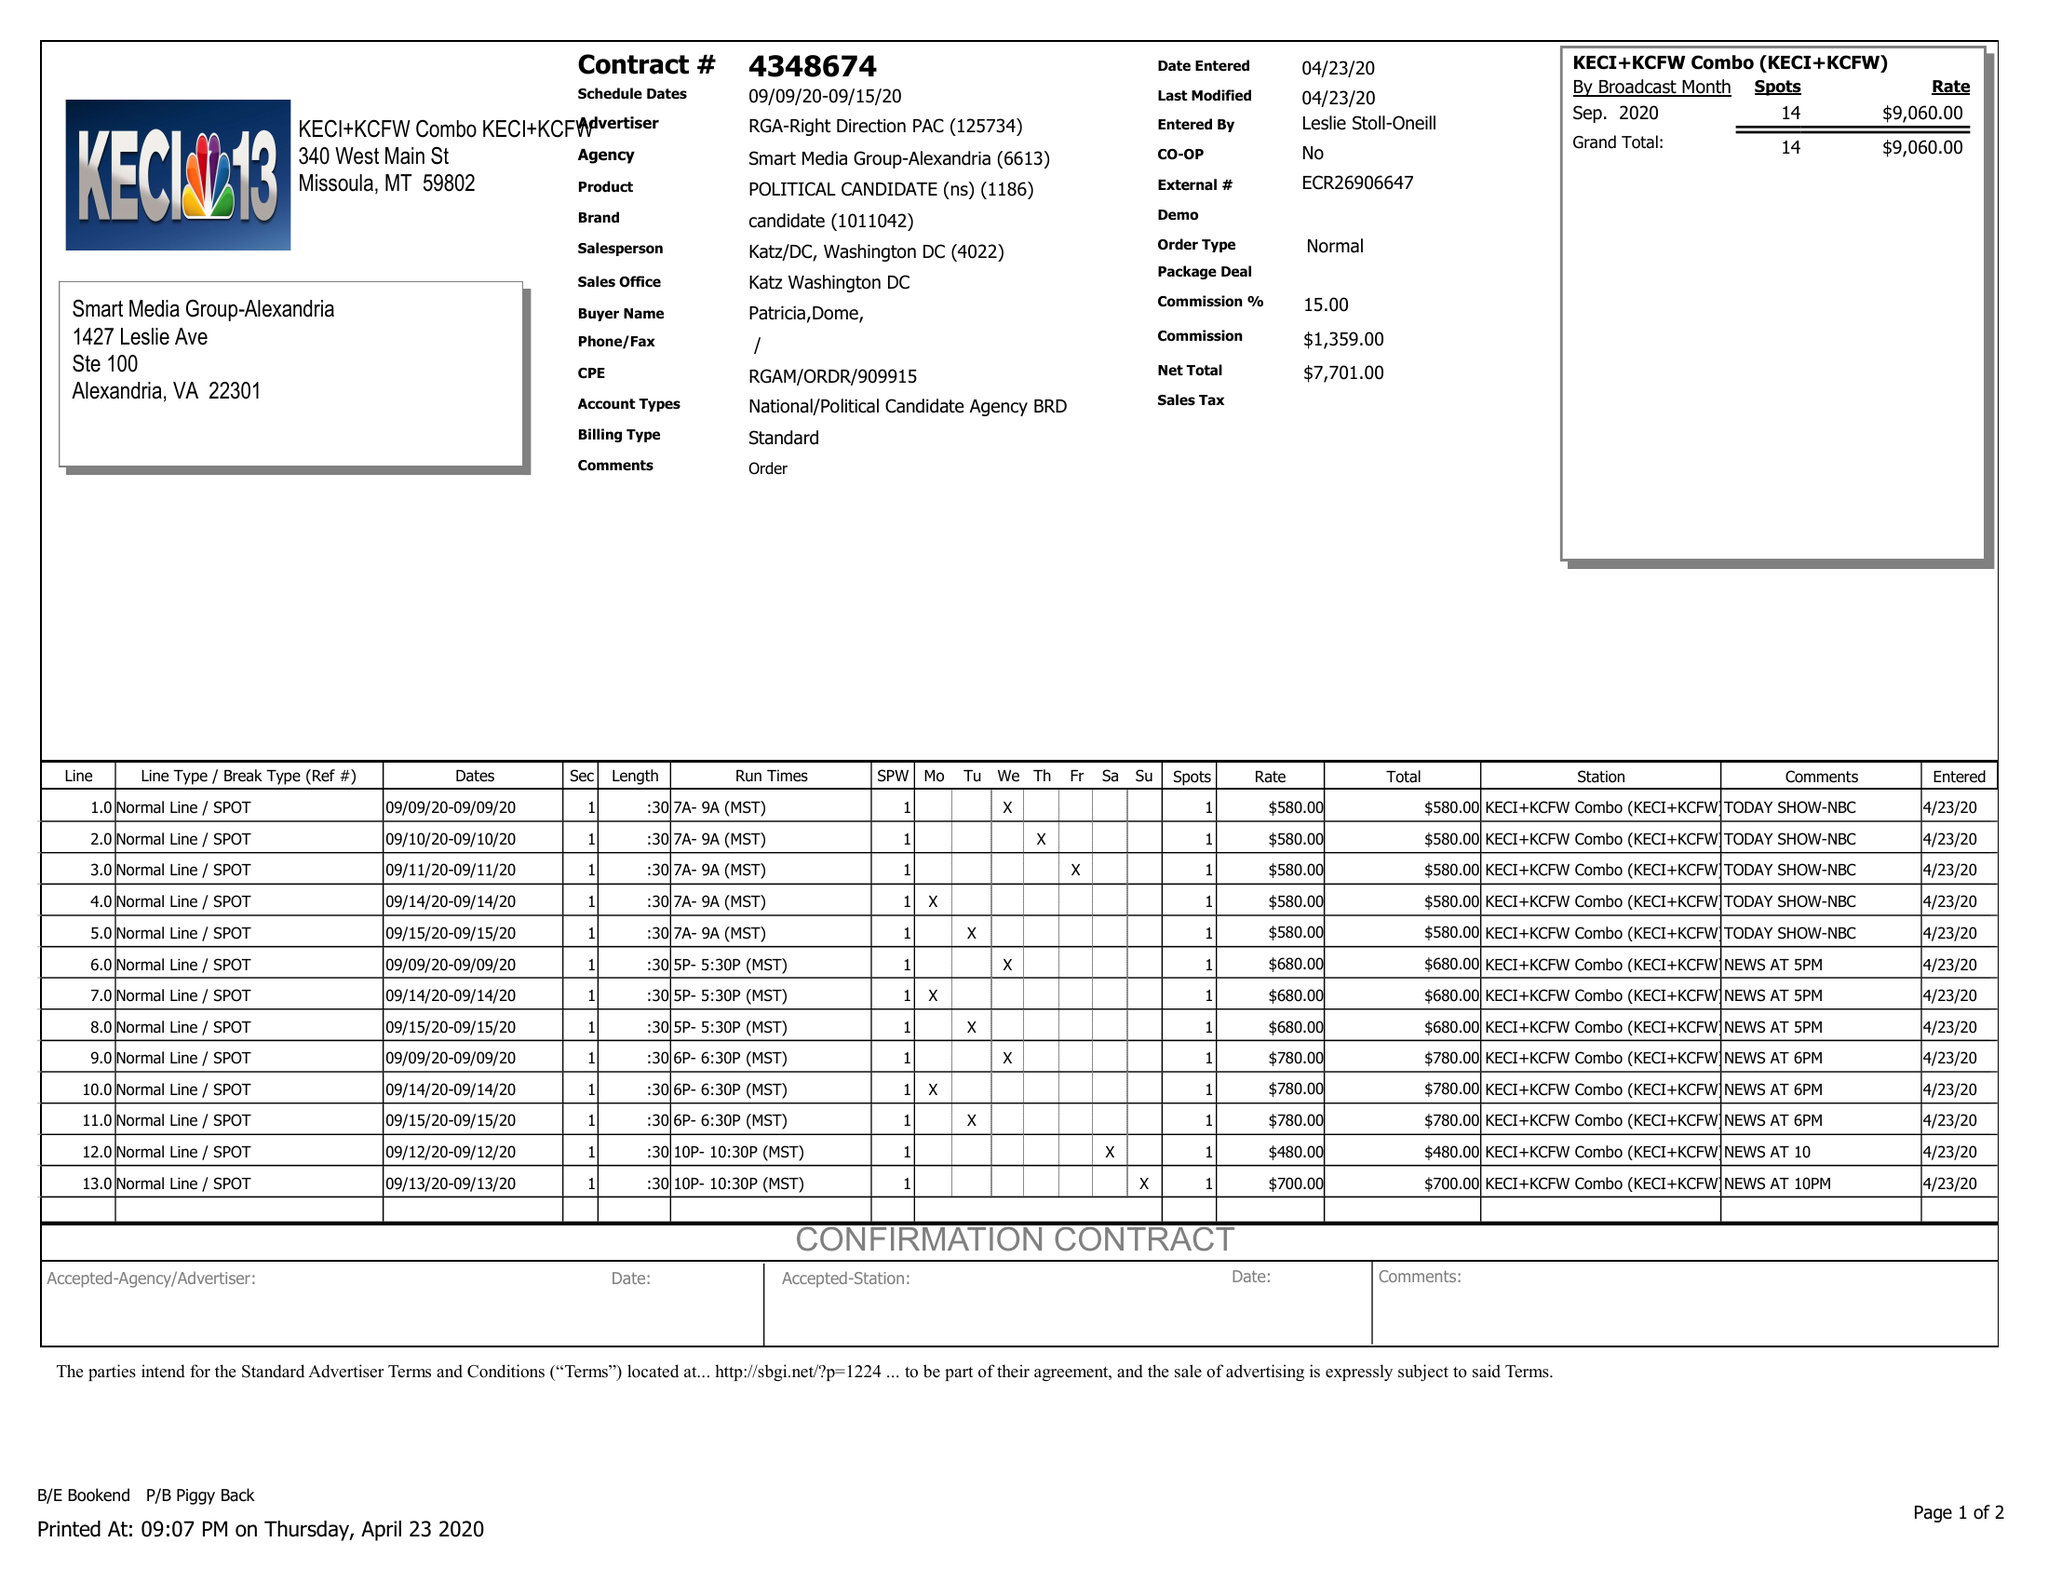What is the value for the flight_to?
Answer the question using a single word or phrase. 09/15/20 